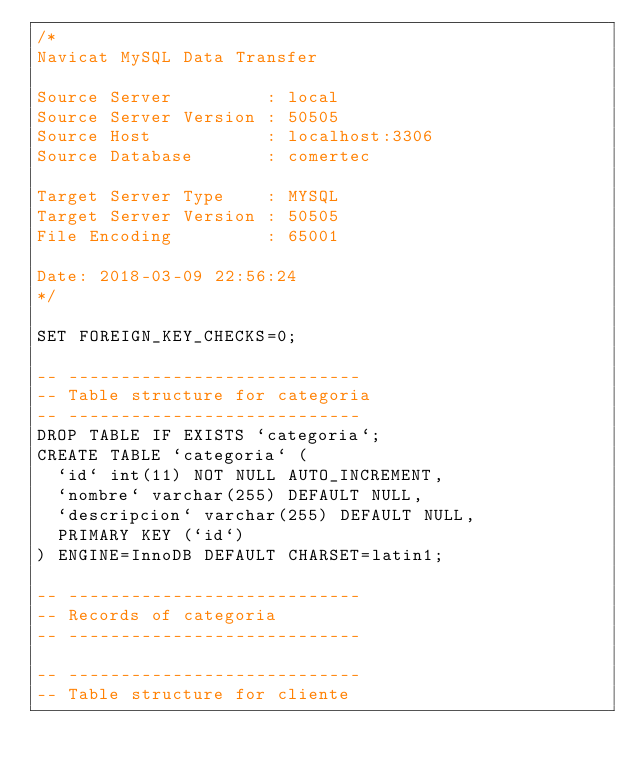<code> <loc_0><loc_0><loc_500><loc_500><_SQL_>/*
Navicat MySQL Data Transfer

Source Server         : local
Source Server Version : 50505
Source Host           : localhost:3306
Source Database       : comertec

Target Server Type    : MYSQL
Target Server Version : 50505
File Encoding         : 65001

Date: 2018-03-09 22:56:24
*/

SET FOREIGN_KEY_CHECKS=0;

-- ----------------------------
-- Table structure for categoria
-- ----------------------------
DROP TABLE IF EXISTS `categoria`;
CREATE TABLE `categoria` (
  `id` int(11) NOT NULL AUTO_INCREMENT,
  `nombre` varchar(255) DEFAULT NULL,
  `descripcion` varchar(255) DEFAULT NULL,
  PRIMARY KEY (`id`)
) ENGINE=InnoDB DEFAULT CHARSET=latin1;

-- ----------------------------
-- Records of categoria
-- ----------------------------

-- ----------------------------
-- Table structure for cliente</code> 